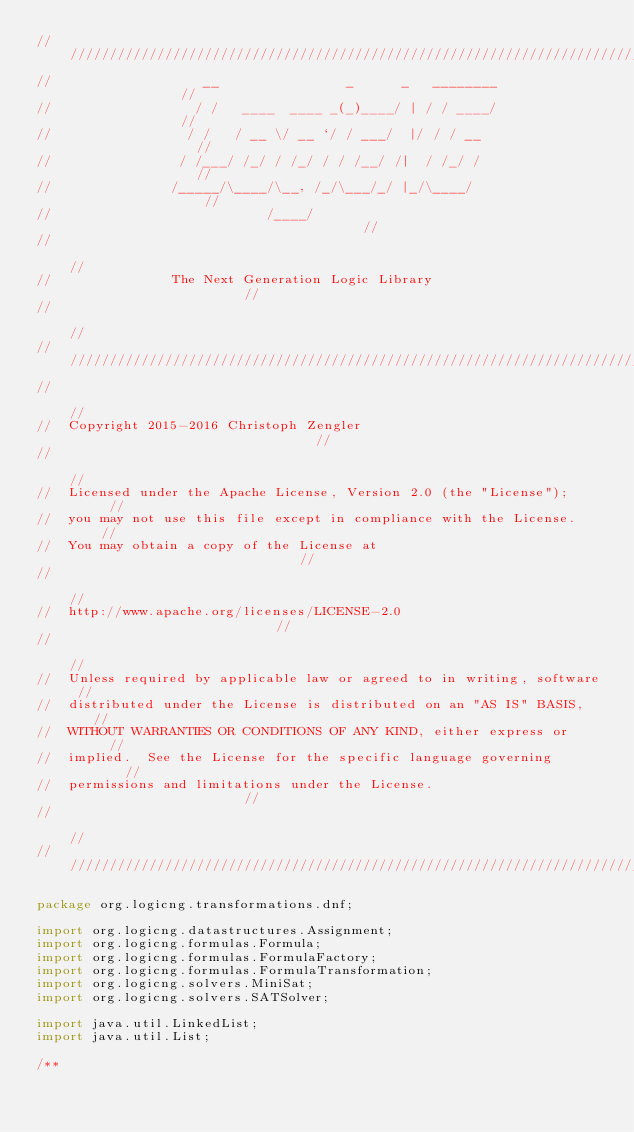<code> <loc_0><loc_0><loc_500><loc_500><_Java_>///////////////////////////////////////////////////////////////////////////
//                   __                _      _   ________               //
//                  / /   ____  ____ _(_)____/ | / / ____/               //
//                 / /   / __ \/ __ `/ / ___/  |/ / / __                 //
//                / /___/ /_/ / /_/ / / /__/ /|  / /_/ /                 //
//               /_____/\____/\__, /_/\___/_/ |_/\____/                  //
//                           /____/                                      //
//                                                                       //
//               The Next Generation Logic Library                       //
//                                                                       //
///////////////////////////////////////////////////////////////////////////
//                                                                       //
//  Copyright 2015-2016 Christoph Zengler                                //
//                                                                       //
//  Licensed under the Apache License, Version 2.0 (the "License");      //
//  you may not use this file except in compliance with the License.     //
//  You may obtain a copy of the License at                              //
//                                                                       //
//  http://www.apache.org/licenses/LICENSE-2.0                           //
//                                                                       //
//  Unless required by applicable law or agreed to in writing, software  //
//  distributed under the License is distributed on an "AS IS" BASIS,    //
//  WITHOUT WARRANTIES OR CONDITIONS OF ANY KIND, either express or      //
//  implied.  See the License for the specific language governing        //
//  permissions and limitations under the License.                       //
//                                                                       //
///////////////////////////////////////////////////////////////////////////

package org.logicng.transformations.dnf;

import org.logicng.datastructures.Assignment;
import org.logicng.formulas.Formula;
import org.logicng.formulas.FormulaFactory;
import org.logicng.formulas.FormulaTransformation;
import org.logicng.solvers.MiniSat;
import org.logicng.solvers.SATSolver;

import java.util.LinkedList;
import java.util.List;

/**</code> 